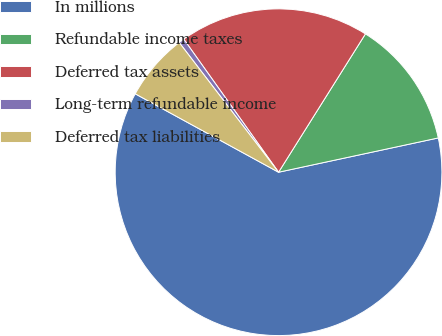Convert chart. <chart><loc_0><loc_0><loc_500><loc_500><pie_chart><fcel>In millions<fcel>Refundable income taxes<fcel>Deferred tax assets<fcel>Long-term refundable income<fcel>Deferred tax liabilities<nl><fcel>61.34%<fcel>12.71%<fcel>18.78%<fcel>0.55%<fcel>6.63%<nl></chart> 